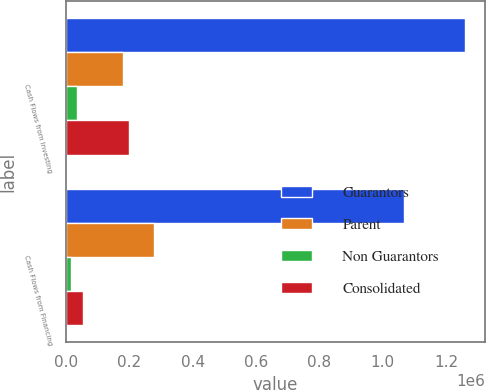<chart> <loc_0><loc_0><loc_500><loc_500><stacked_bar_chart><ecel><fcel>Cash Flows from Investing<fcel>Cash Flows from Financing<nl><fcel>Guarantors<fcel>1.25893e+06<fcel>1.06572e+06<nl><fcel>Parent<fcel>180800<fcel>277430<nl><fcel>Non Guarantors<fcel>36162<fcel>15803<nl><fcel>Consolidated<fcel>198374<fcel>55234<nl></chart> 